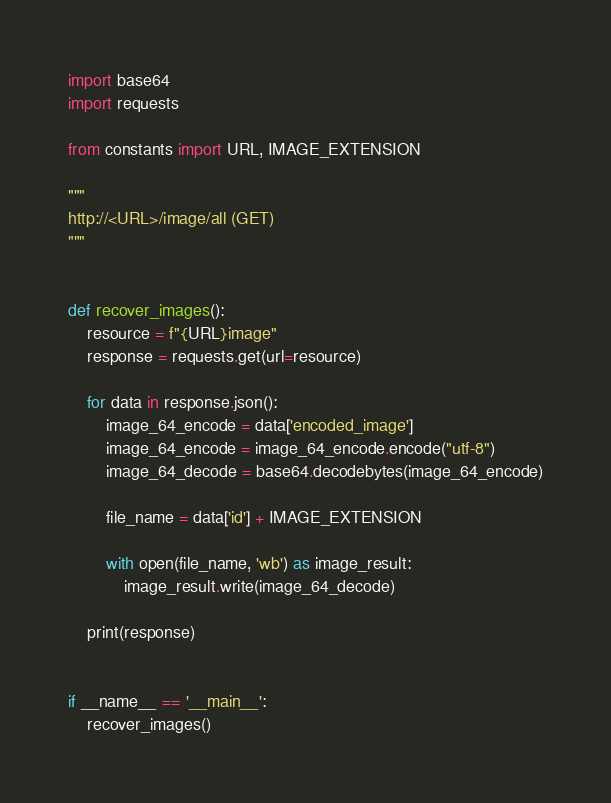<code> <loc_0><loc_0><loc_500><loc_500><_Python_>import base64
import requests

from constants import URL, IMAGE_EXTENSION

"""
http://<URL>/image/all (GET)
"""


def recover_images():
    resource = f"{URL}image"
    response = requests.get(url=resource)

    for data in response.json():
        image_64_encode = data['encoded_image']
        image_64_encode = image_64_encode.encode("utf-8")
        image_64_decode = base64.decodebytes(image_64_encode)

        file_name = data['id'] + IMAGE_EXTENSION

        with open(file_name, 'wb') as image_result:
            image_result.write(image_64_decode)

    print(response)


if __name__ == '__main__':
    recover_images()
</code> 